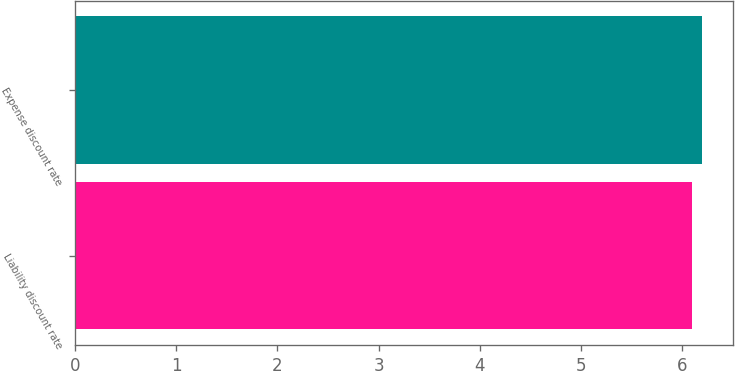<chart> <loc_0><loc_0><loc_500><loc_500><bar_chart><fcel>Liability discount rate<fcel>Expense discount rate<nl><fcel>6.1<fcel>6.2<nl></chart> 